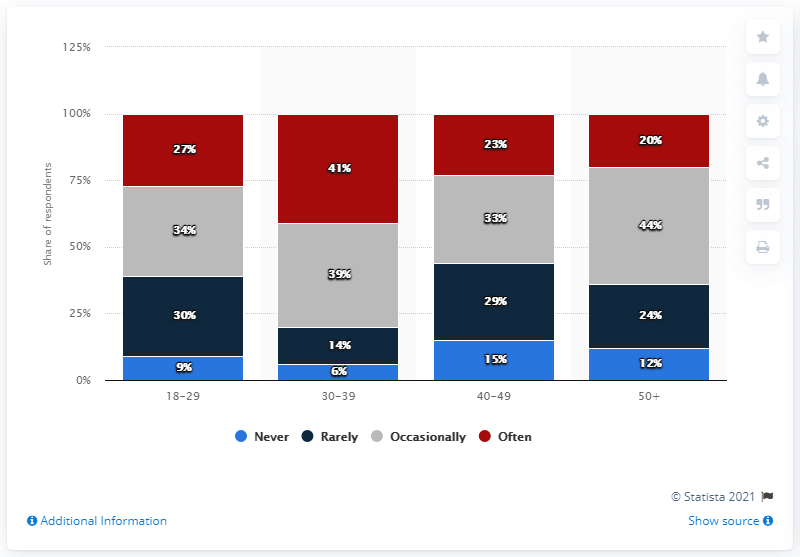Outline some significant characteristics in this image. The smallest categories across all age groups add up to 42. The red bar represents the category of often in the Venn diagram. 